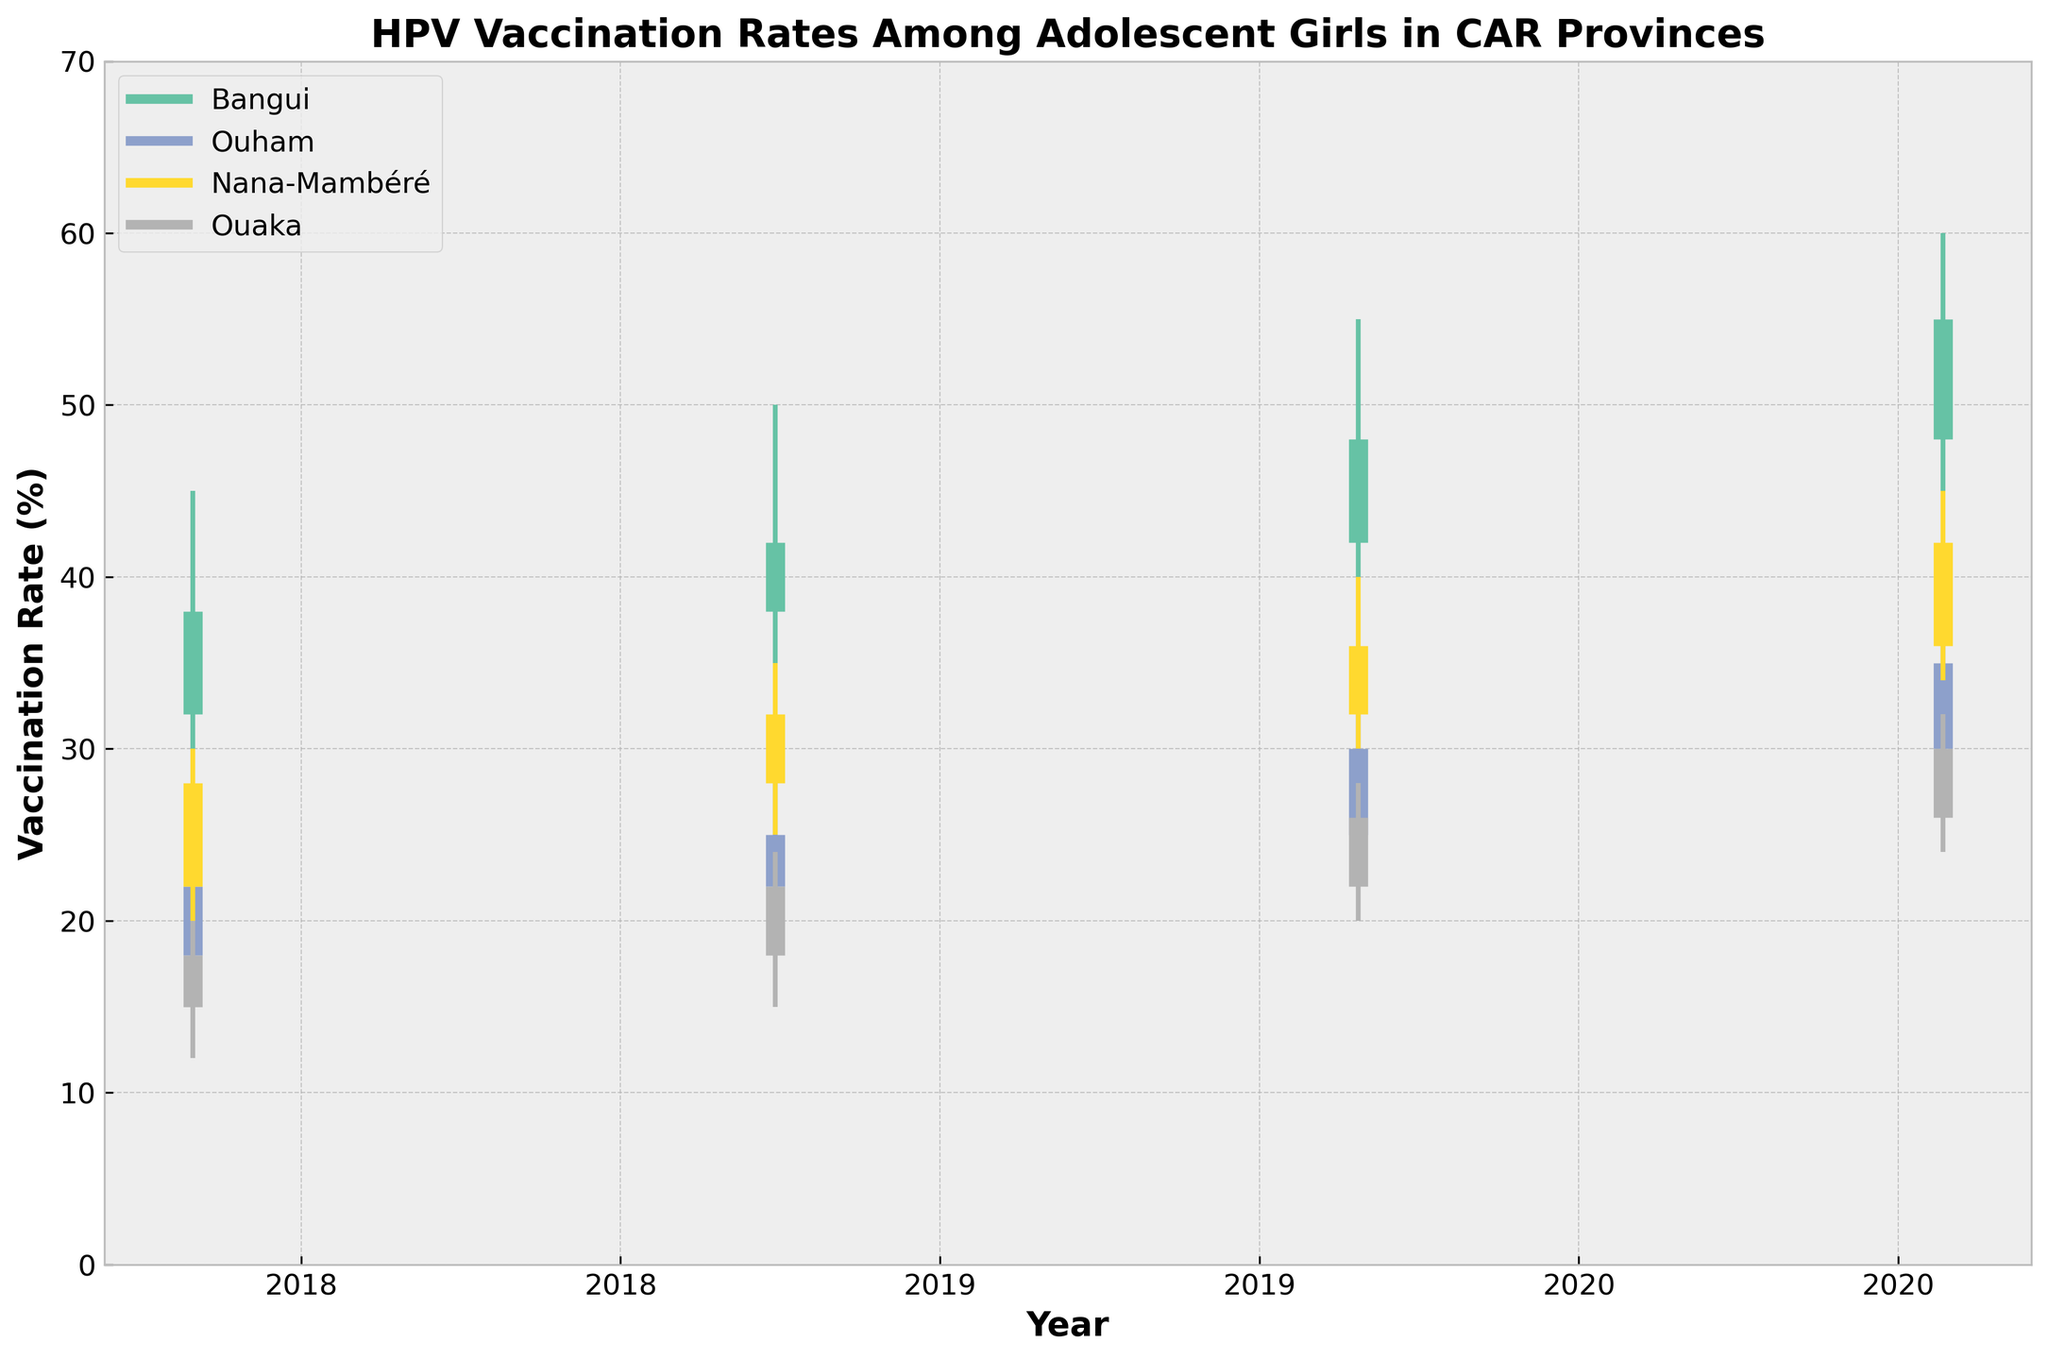what is the title of the figure? The title of a figure is typically found at the top and summarizes its main focus. In this case, the title directly says what the chart is about.
Answer: HPV Vaccination Rates Among Adolescent Girls in CAR Provinces Which province had the highest 'Close' value in 2021? To find out which province had the highest 'Close' value, look at the closing bars in the year 2021 and identify the tallest one.
Answer: Bangui What was the highest vaccination rate recorded in Bangui across all years? The 'High' value represents the highest rate within a year. By comparing the 'High' values for Bangui from 2018 to 2021, we see that 2021 has the highest 'High' value of 60%.
Answer: 60 Which province showed the greatest increase in 'Close' values from 2018 to 2021? Calculate the difference in 'Close' values from 2018 to 2021 for each province and compare them. Bangui shows an increase from 38 to 55, a total increase of 17%. Ouham increased from 22 to 35 (13%). Nana-Mambéré increased from 28 to 42 (14%). Ouaka increased from 18 to 30 (12%).
Answer: Bangui How did the vaccination rate in Ouham change between 2018 and 2021? By comparing the 'Close' values for Ouham in 2018 and 2021, we see that it increased from 22% to 35%.
Answer: Increased by 13% Which year did Ouaka achieve the highest 'Close' value? Look at the 'Close' values for Ouaka over the years. The highest 'Close' value for Ouaka is 30%, which occurred in 2021.
Answer: 2021 Is there any province where the 'Close' value decreased from 2020 to 2021? Compare the 'Close' values from 2020 to 2021 for each province. None of the provinces show a decrease; all show an increase in 'Close' values.
Answer: No Which province had the lowest 'Open' value in 2019 and what was it? Examine the 'Open' values for each province in 2019 to identify the lowest one. The lowest 'Open' value in 2019 is 18, found in Ouaka.
Answer: Ouaka, 18 Did Bangui's 'Low' value ever increase over consecutive years? Evaluate the 'Low' values for Bangui over the years and note increases. In Bangui, the 'Low' values increased every year from 2018 to 2021: 2018 (30%), 2019 (35%), 2020 (40%), and 2021 (45%).
Answer: Yes In which year did Nana-Mambéré achieve its highest 'High' value, and what was the value? Look at the 'High' values for Nana-Mambéré over the years. The highest 'High' value for Nana-Mambéré occurred in 2021, with a value of 45%.
Answer: 2021, 45% 